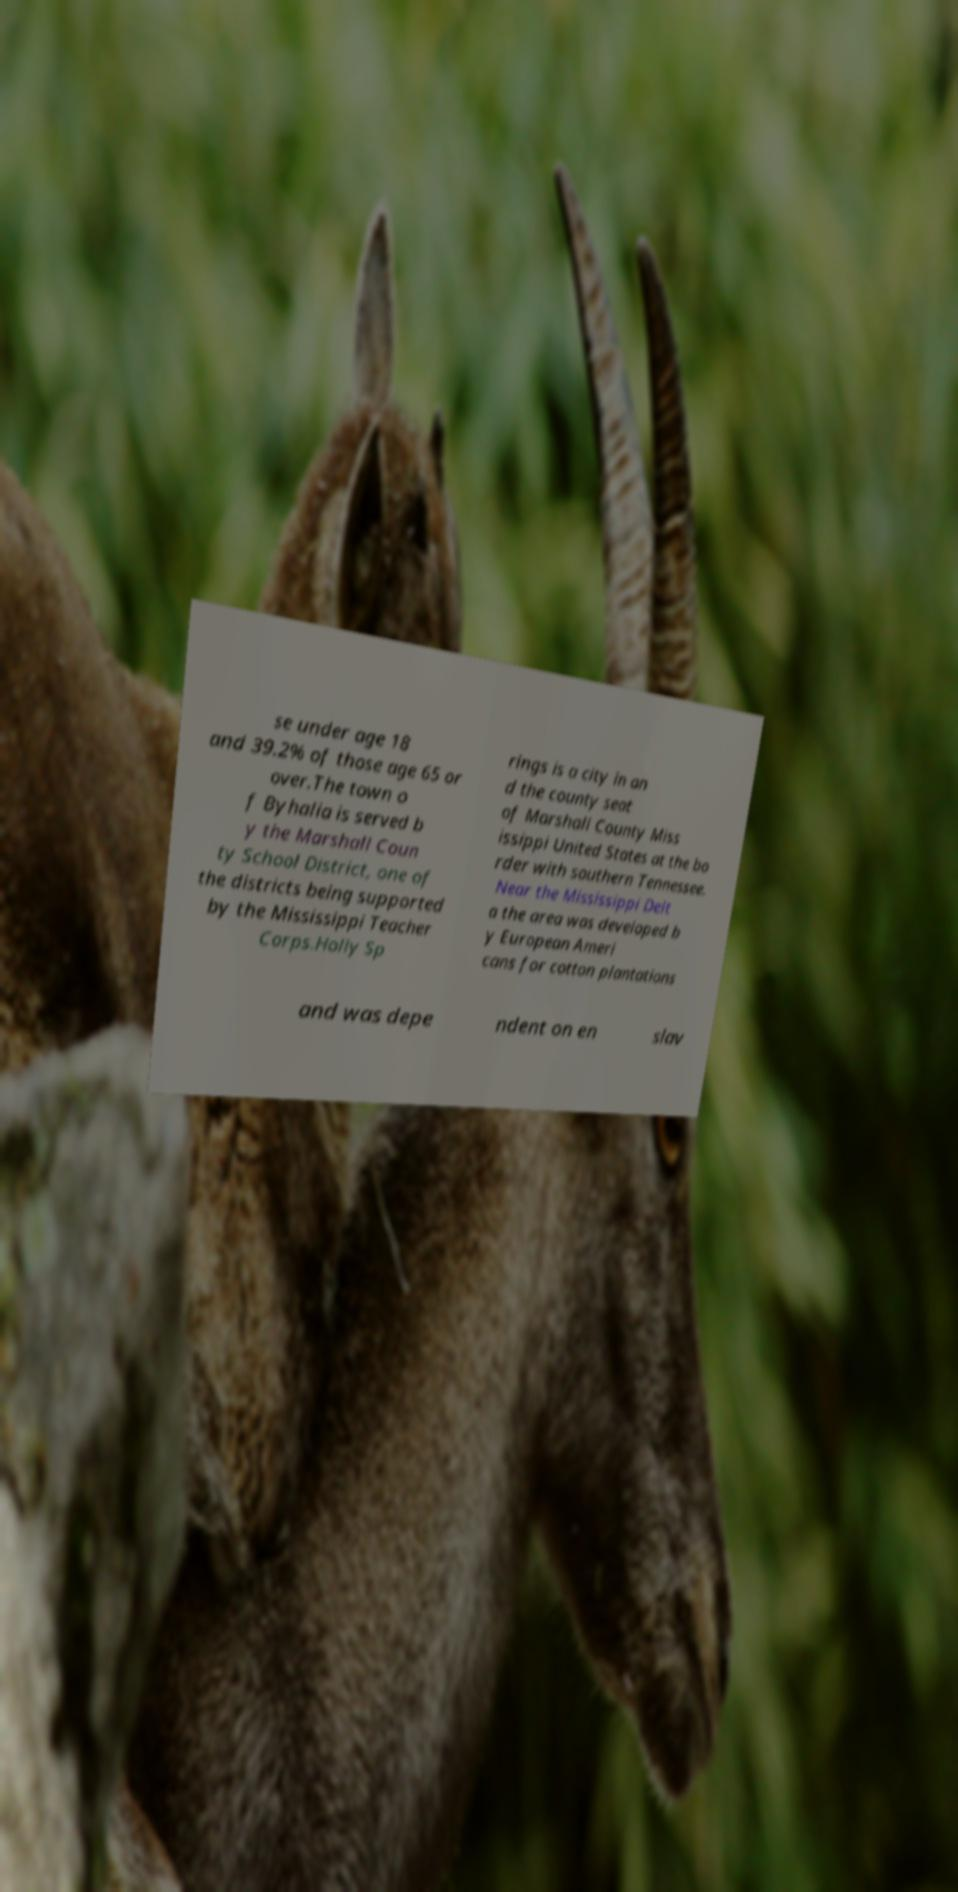What messages or text are displayed in this image? I need them in a readable, typed format. se under age 18 and 39.2% of those age 65 or over.The town o f Byhalia is served b y the Marshall Coun ty School District, one of the districts being supported by the Mississippi Teacher Corps.Holly Sp rings is a city in an d the county seat of Marshall County Miss issippi United States at the bo rder with southern Tennessee. Near the Mississippi Delt a the area was developed b y European Ameri cans for cotton plantations and was depe ndent on en slav 